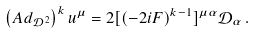<formula> <loc_0><loc_0><loc_500><loc_500>\left ( A d _ { \mathcal { D } ^ { 2 } } \right ) ^ { k } u ^ { \mu } = 2 [ ( - 2 i F ) ^ { k - 1 } ] ^ { \mu \alpha } \mathcal { D } _ { \alpha } \, .</formula> 